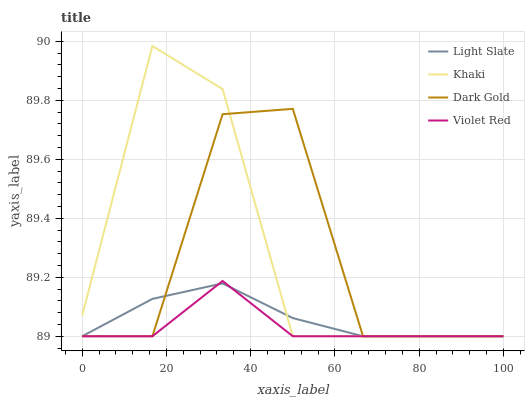Does Violet Red have the minimum area under the curve?
Answer yes or no. Yes. Does Khaki have the maximum area under the curve?
Answer yes or no. Yes. Does Khaki have the minimum area under the curve?
Answer yes or no. No. Does Violet Red have the maximum area under the curve?
Answer yes or no. No. Is Light Slate the smoothest?
Answer yes or no. Yes. Is Dark Gold the roughest?
Answer yes or no. Yes. Is Violet Red the smoothest?
Answer yes or no. No. Is Violet Red the roughest?
Answer yes or no. No. Does Khaki have the highest value?
Answer yes or no. Yes. Does Violet Red have the highest value?
Answer yes or no. No. Does Dark Gold intersect Violet Red?
Answer yes or no. Yes. Is Dark Gold less than Violet Red?
Answer yes or no. No. Is Dark Gold greater than Violet Red?
Answer yes or no. No. 